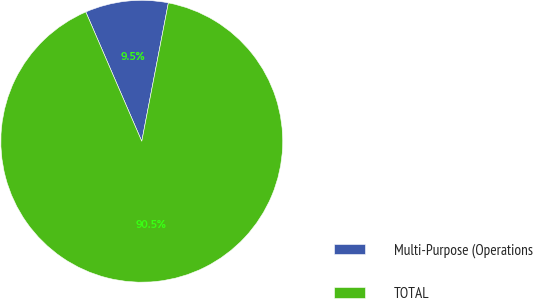<chart> <loc_0><loc_0><loc_500><loc_500><pie_chart><fcel>Multi-Purpose (Operations<fcel>TOTAL<nl><fcel>9.52%<fcel>90.48%<nl></chart> 